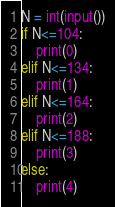Convert code to text. <code><loc_0><loc_0><loc_500><loc_500><_Python_>N = int(input())
if N<=104:
    print(0)
elif N<=134:
    print(1)
elif N<=164:
    print(2)
elif N<=188:
    print(3)
else:
    print(4)</code> 